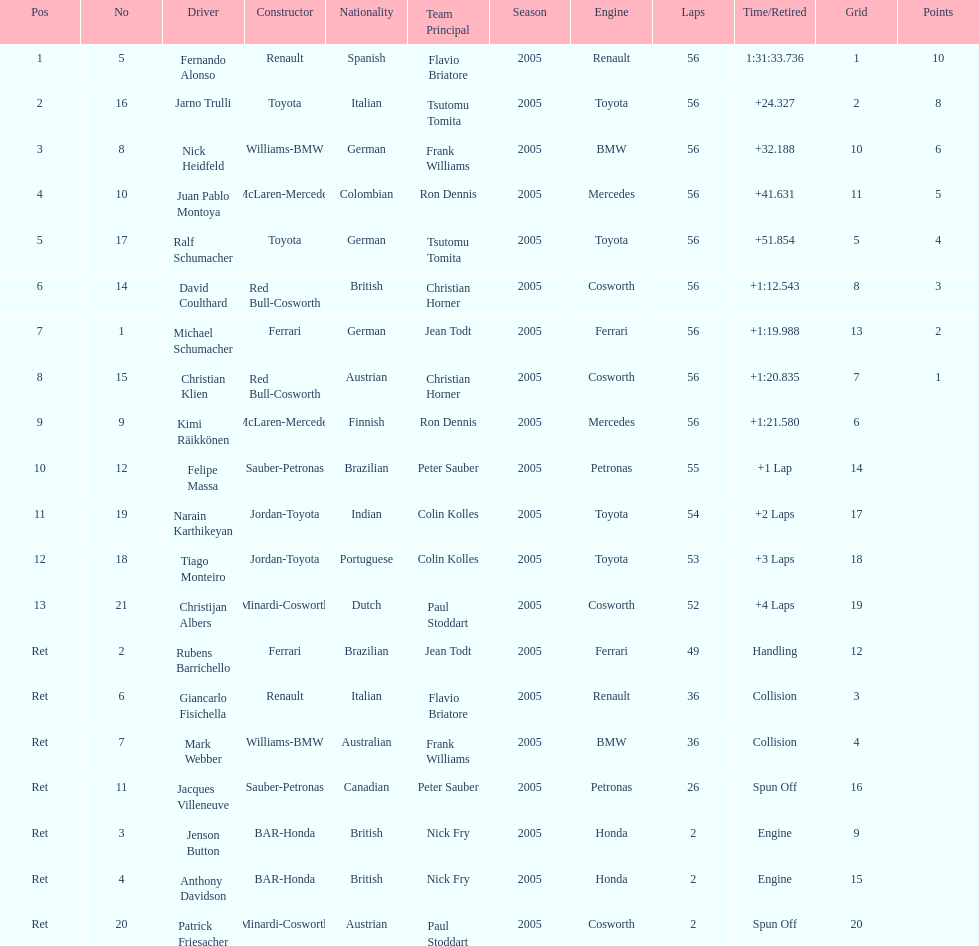What driver finished first? Fernando Alonso. 